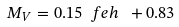<formula> <loc_0><loc_0><loc_500><loc_500>M _ { V } = 0 . 1 5 \ f e h \ + 0 . 8 3</formula> 